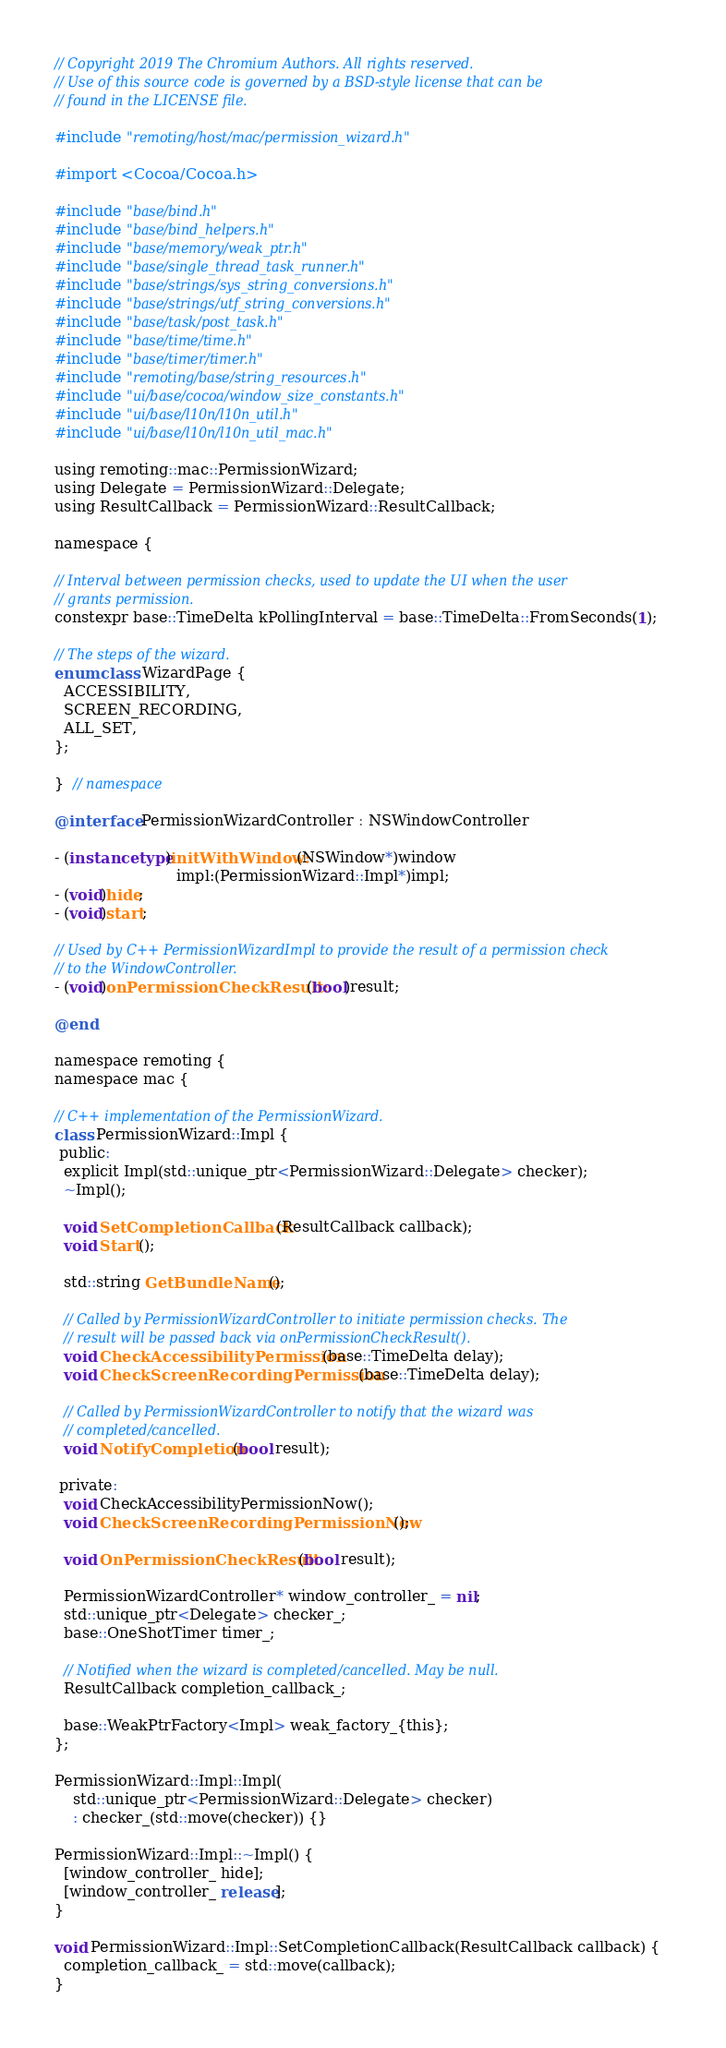<code> <loc_0><loc_0><loc_500><loc_500><_ObjectiveC_>// Copyright 2019 The Chromium Authors. All rights reserved.
// Use of this source code is governed by a BSD-style license that can be
// found in the LICENSE file.

#include "remoting/host/mac/permission_wizard.h"

#import <Cocoa/Cocoa.h>

#include "base/bind.h"
#include "base/bind_helpers.h"
#include "base/memory/weak_ptr.h"
#include "base/single_thread_task_runner.h"
#include "base/strings/sys_string_conversions.h"
#include "base/strings/utf_string_conversions.h"
#include "base/task/post_task.h"
#include "base/time/time.h"
#include "base/timer/timer.h"
#include "remoting/base/string_resources.h"
#include "ui/base/cocoa/window_size_constants.h"
#include "ui/base/l10n/l10n_util.h"
#include "ui/base/l10n/l10n_util_mac.h"

using remoting::mac::PermissionWizard;
using Delegate = PermissionWizard::Delegate;
using ResultCallback = PermissionWizard::ResultCallback;

namespace {

// Interval between permission checks, used to update the UI when the user
// grants permission.
constexpr base::TimeDelta kPollingInterval = base::TimeDelta::FromSeconds(1);

// The steps of the wizard.
enum class WizardPage {
  ACCESSIBILITY,
  SCREEN_RECORDING,
  ALL_SET,
};

}  // namespace

@interface PermissionWizardController : NSWindowController

- (instancetype)initWithWindow:(NSWindow*)window
                          impl:(PermissionWizard::Impl*)impl;
- (void)hide;
- (void)start;

// Used by C++ PermissionWizardImpl to provide the result of a permission check
// to the WindowController.
- (void)onPermissionCheckResult:(bool)result;

@end

namespace remoting {
namespace mac {

// C++ implementation of the PermissionWizard.
class PermissionWizard::Impl {
 public:
  explicit Impl(std::unique_ptr<PermissionWizard::Delegate> checker);
  ~Impl();

  void SetCompletionCallback(ResultCallback callback);
  void Start();

  std::string GetBundleName();

  // Called by PermissionWizardController to initiate permission checks. The
  // result will be passed back via onPermissionCheckResult().
  void CheckAccessibilityPermission(base::TimeDelta delay);
  void CheckScreenRecordingPermission(base::TimeDelta delay);

  // Called by PermissionWizardController to notify that the wizard was
  // completed/cancelled.
  void NotifyCompletion(bool result);

 private:
  void CheckAccessibilityPermissionNow();
  void CheckScreenRecordingPermissionNow();

  void OnPermissionCheckResult(bool result);

  PermissionWizardController* window_controller_ = nil;
  std::unique_ptr<Delegate> checker_;
  base::OneShotTimer timer_;

  // Notified when the wizard is completed/cancelled. May be null.
  ResultCallback completion_callback_;

  base::WeakPtrFactory<Impl> weak_factory_{this};
};

PermissionWizard::Impl::Impl(
    std::unique_ptr<PermissionWizard::Delegate> checker)
    : checker_(std::move(checker)) {}

PermissionWizard::Impl::~Impl() {
  [window_controller_ hide];
  [window_controller_ release];
}

void PermissionWizard::Impl::SetCompletionCallback(ResultCallback callback) {
  completion_callback_ = std::move(callback);
}
</code> 